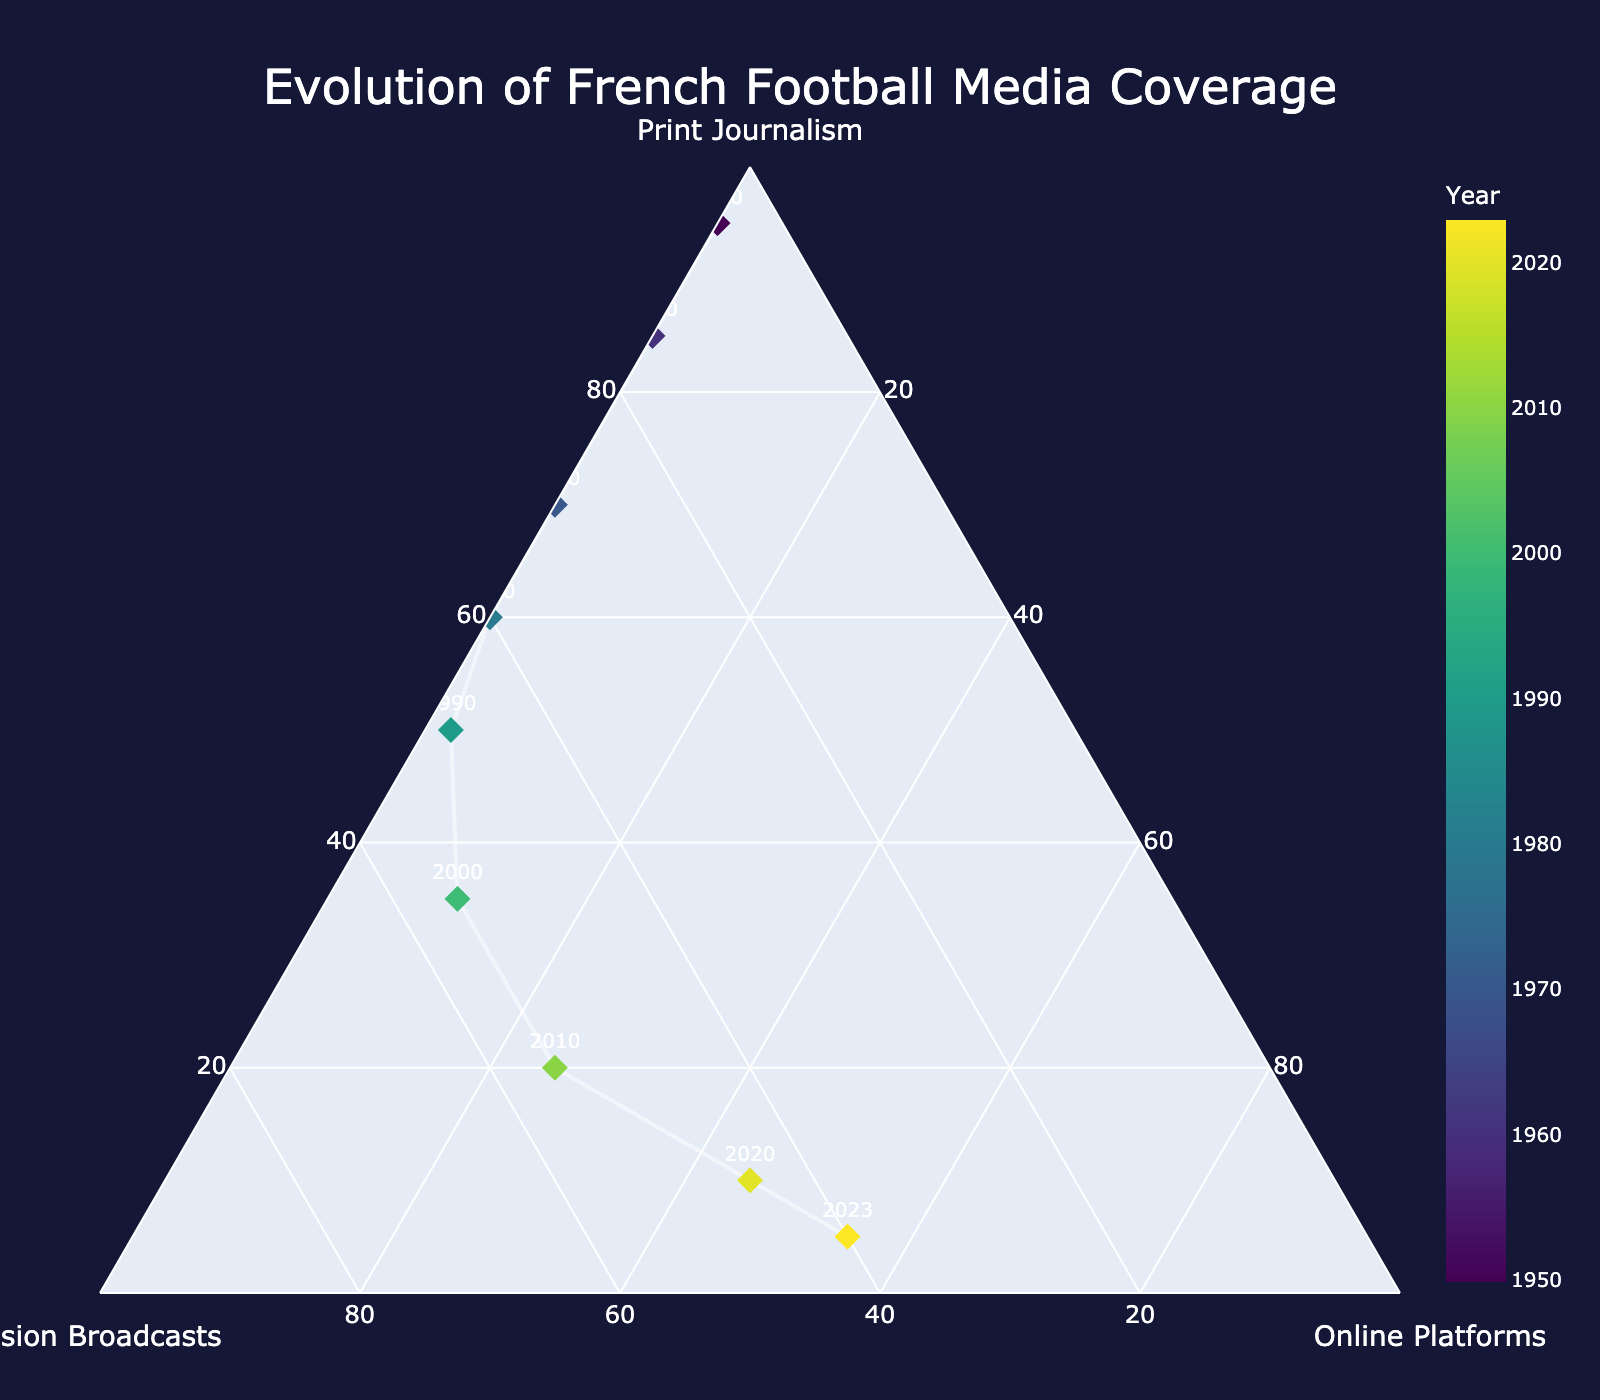What are the three main types of media coverage shown in the plot? The plot axes titles indicate the three types of media coverage: Print Journalism, Television Broadcasts, and Online Platforms.
Answer: Print Journalism, Television Broadcasts, Online Platforms What is the title of the ternary plot? The title is prominently displayed at the top of the plot, which reads "Evolution of French Football Media Coverage".
Answer: Evolution of French Football Media Coverage In the year 1950, which medium had the highest percentage of coverage? By examining the marker corresponding to 1950, we see it is located near the apex labeled "Print Journalism," indicating the highest coverage in that year.
Answer: Print Journalism How does the percentage of online platform coverage change from 2000 to 2023? Comparing the marker positions from 2000 to 2023, the percentage along the "Online Platforms" apex increases significantly.
Answer: It increases significantly Which year marks the first presence of online platforms in the media coverage? The plot shows near the axis of "Online Platforms" a non-zero value around the year 1990.
Answer: 1990 When did print journalism coverage drop below 50%? By observing the plot markers, one can see that in the year 2000, Print Journalism is less than 50%.
Answer: 2000 What can you infer about the trend in television broadcasts coverage from 1950 to 2023? The markers show television broadcasts coverage increasing steadily from 1950 to 2000, then stabilizing and slightly decreasing by 2023.
Answer: Increasing then slightly decreasing Which period shows the fastest decline in print journalism coverage? The sharpest decline is evident between 2000 and 2010, where the markers show a steep drop in Print Journalism coverage.
Answer: 2000 to 2010 In which year do online platforms surpass print journalism coverage? Examining the markers, it is noticeable that in 2020, the online platforms' percentage first exceeds that of print journalism.
Answer: 2020 What is the coverage distribution for the year 2023? The marker for 2023 is nearest to the "Online Platforms" and equally distributed between "Television Broadcasts" and "Print Journalism."
Answer: Print Journalism: 5%, Television Broadcasts: 40%, Online Platforms: 55% 